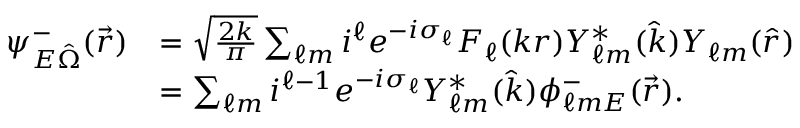<formula> <loc_0><loc_0><loc_500><loc_500>\begin{array} { r l } { \psi _ { E \hat { \Omega } } ^ { - } ( \vec { r } ) } & { = \sqrt { \frac { 2 k } { \pi } } \sum _ { \ell m } i ^ { \ell } e ^ { - i \sigma _ { \ell } } F _ { \ell } ( k r ) Y _ { \ell m } ^ { * } ( \hat { k } ) Y _ { \ell m } ( \hat { r } ) } \\ & { = \sum _ { \ell m } i ^ { \ell - 1 } e ^ { - i \sigma _ { \ell } } Y _ { \ell m } ^ { * } ( \hat { k } ) \phi _ { \ell m E } ^ { - } ( \vec { r } ) . } \end{array}</formula> 